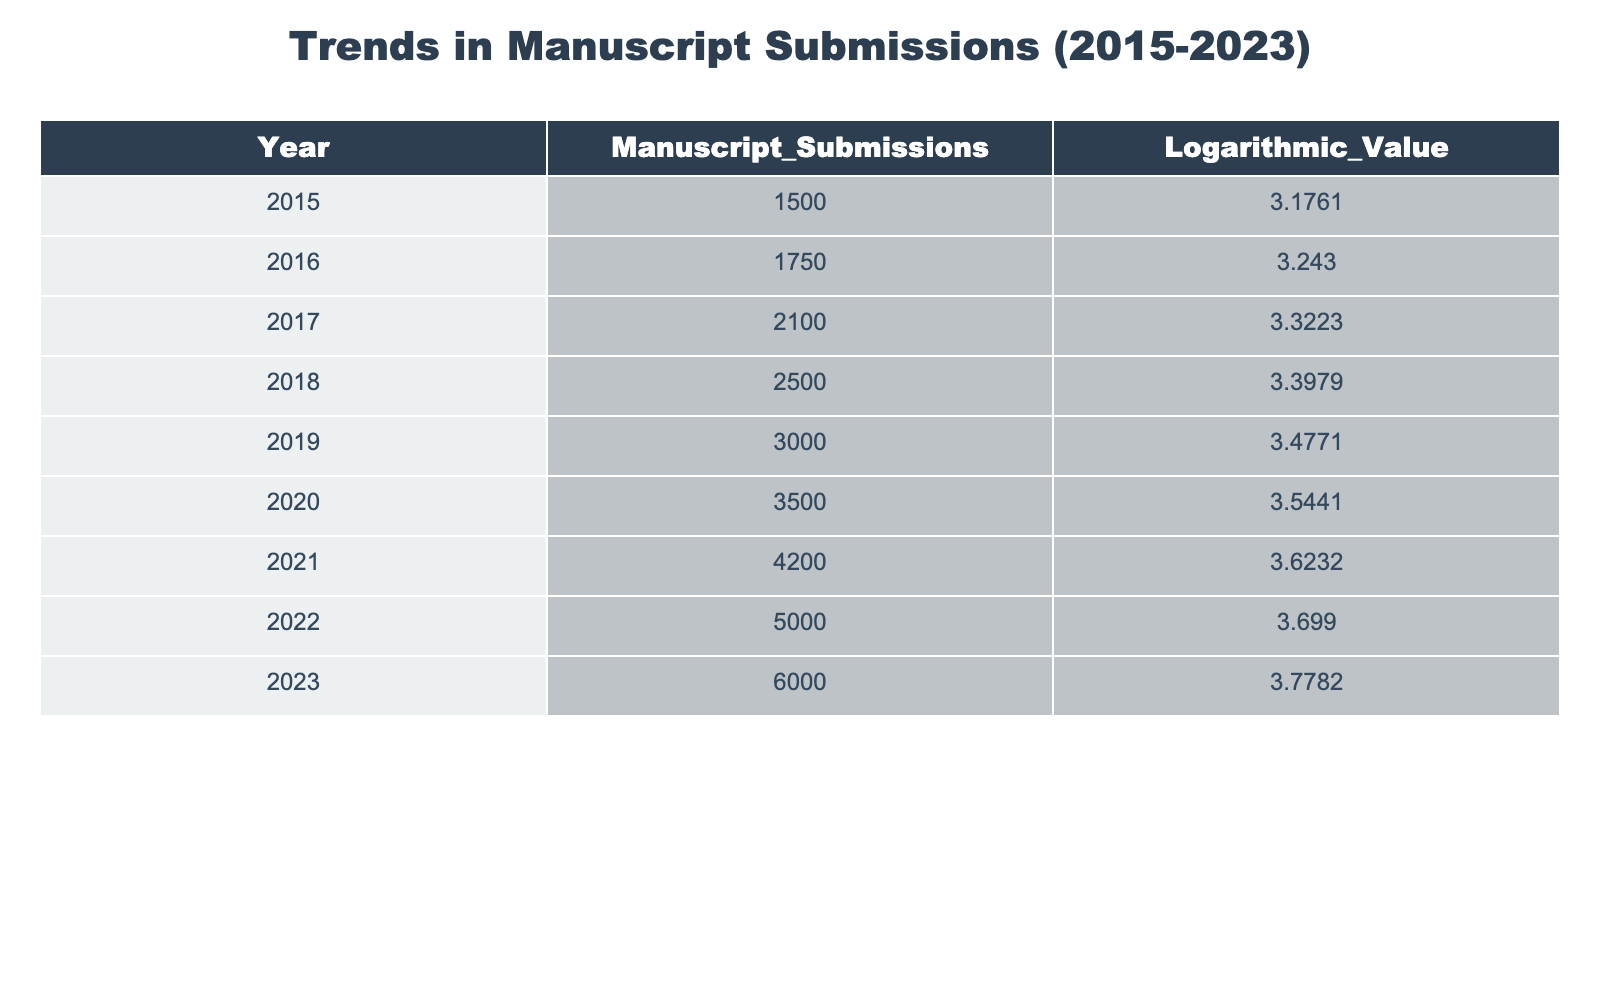What was the number of manuscript submissions in 2019? The table shows the "Manuscript_Submissions" for each year. For 2019, the value listed is 3000.
Answer: 3000 What is the logarithmic value for manuscript submissions in 2022? By checking the table for the year 2022, the logarithmic value associated with that year is 3.6990.
Answer: 3.6990 What year had the highest number of manuscript submissions? The table indicates the highest number of manuscript submissions occurred in 2023, with a value of 6000.
Answer: 2023 What is the difference in manuscript submissions between 2015 and 2023? The submissions in 2015 were 1500, and in 2023 they were 6000. The difference is calculated as 6000 - 1500 = 4500.
Answer: 4500 Is the number of manuscript submissions in 2020 greater than in 2018? The submissions for 2020 are 3500, while for 2018 they are 2500. Comparing the two, 3500 > 2500, thus the statement is true.
Answer: Yes What is the average number of manuscript submissions from 2015 to 2022? The total submissions from 2015 to 2022 are calculated by adding them together: 1500 + 1750 + 2100 + 2500 + 3000 + 3500 + 4200 + 5000 = 21550. There are 8 years, so the average is 21550 / 8 = 2693.75.
Answer: 2693.75 What is the total logarithmic value of manuscript submissions from 2015 to 2023? To find the total logarithmic value, we add all the logarithmic values from the table: 3.1761 + 3.2430 + 3.3223 + 3.3979 + 3.4771 + 3.5441 + 3.6232 + 3.6990 + 3.7782 = 30.4109.
Answer: 30.4109 How many manuscript submissions were there in 2021 compared to 2016? The number of submissions in 2021 is 4200, and in 2016 is 1750. This shows that 4200 is greater than 1750.
Answer: 4200 > 1750 Was there an increase in manuscript submissions every year from 2015 to 2023? Checking each year from the table, submissions increased from 1500 in 2015 to 6000 in 2023 without any decreases in between. Therefore, the statement is true.
Answer: Yes 